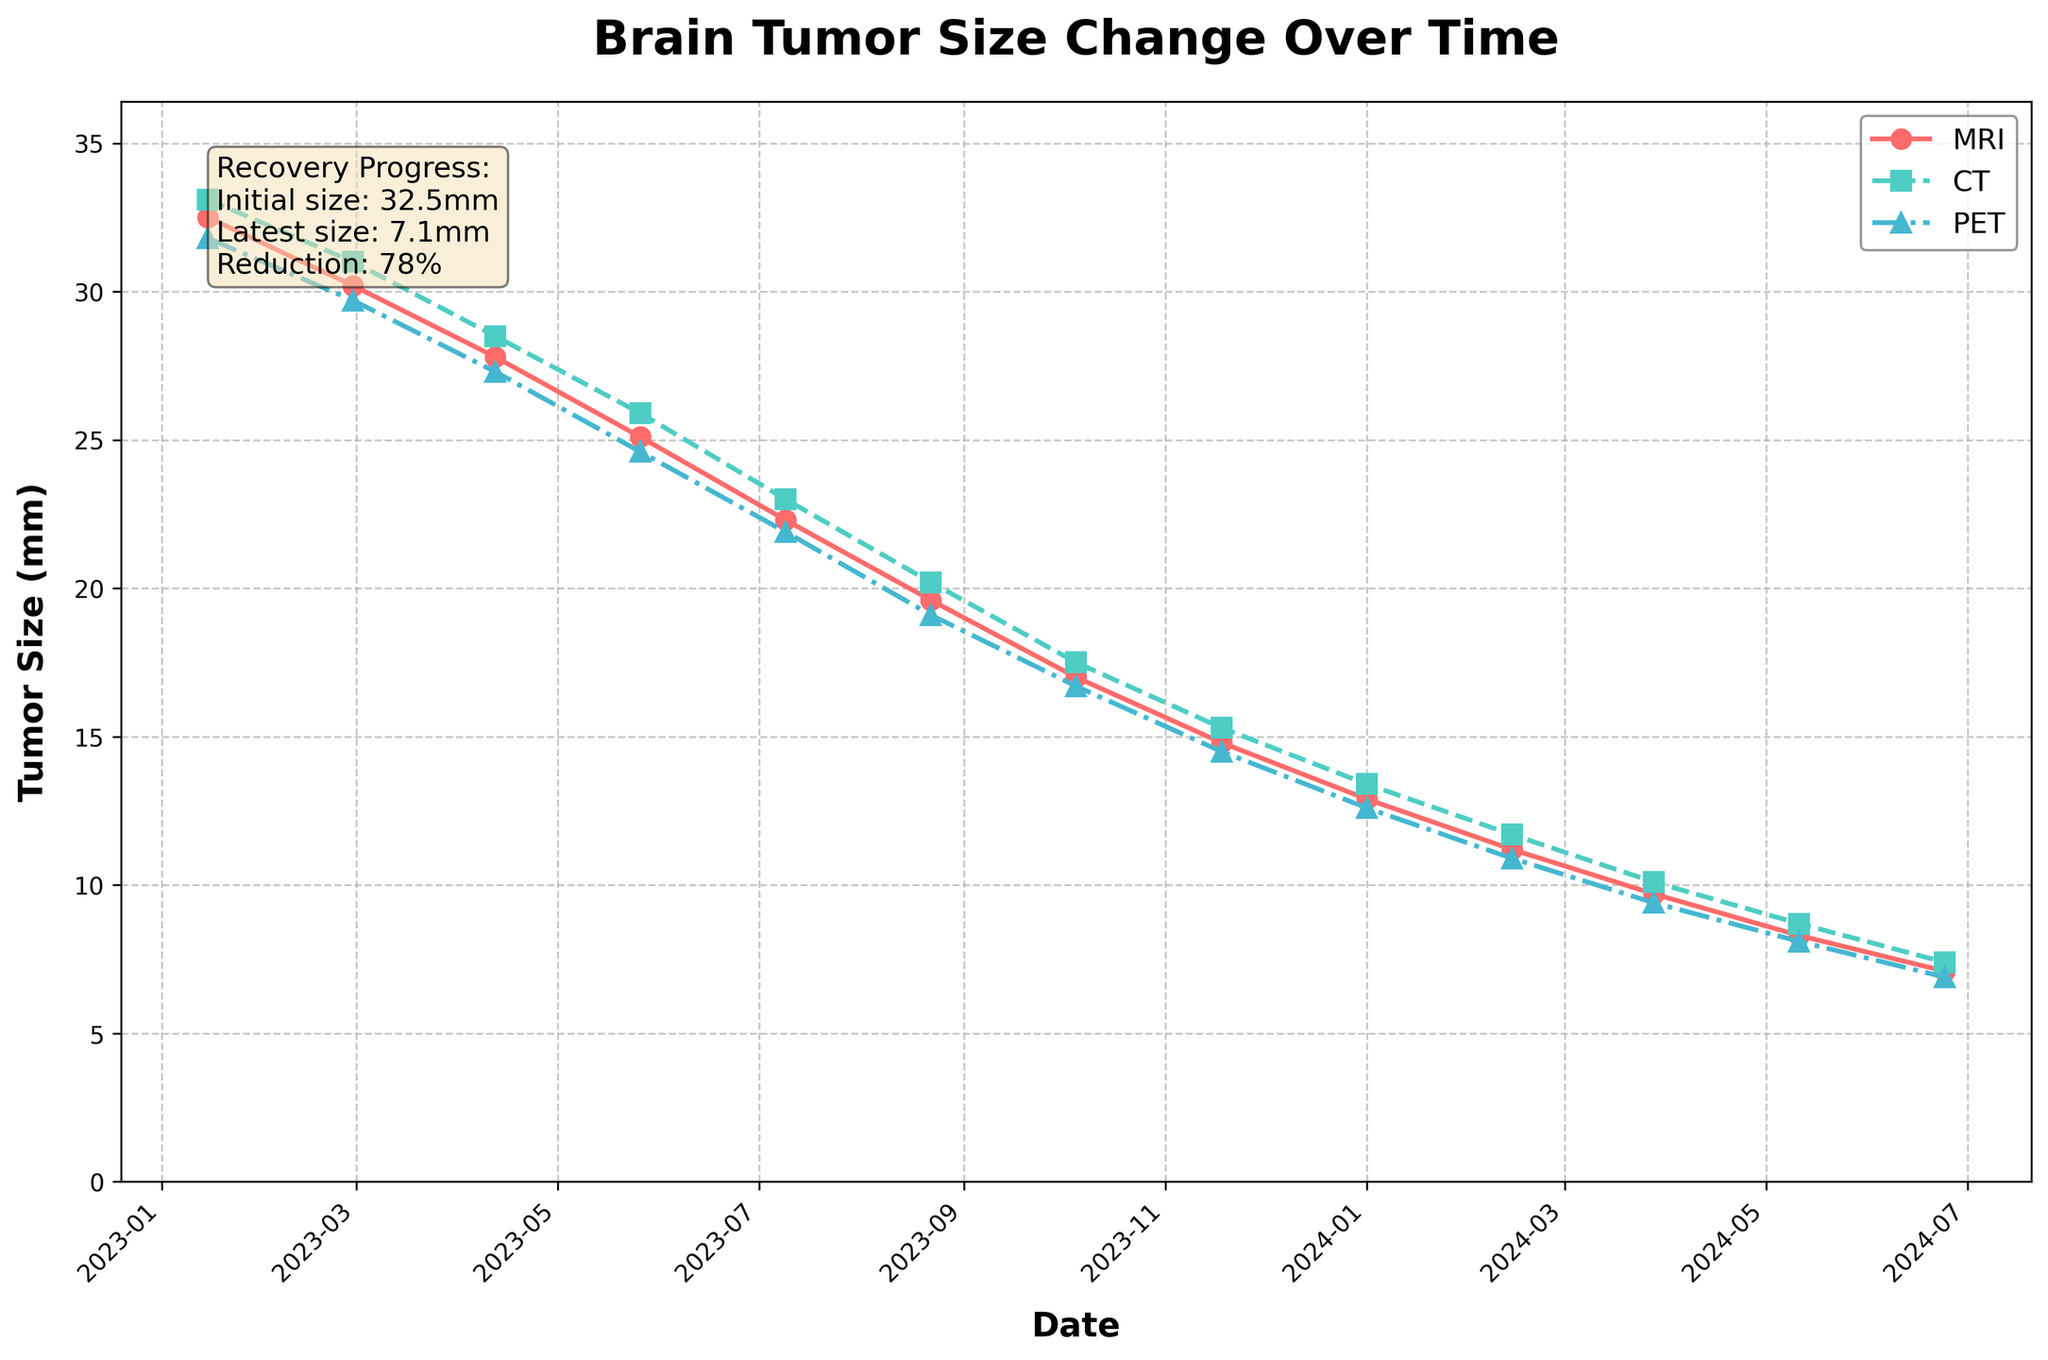What's the general trend of brain tumor size over time for all three imaging techniques? The plot shows that the brain tumor size for all three techniques (MRI, CT, PET) decreases over time. This can be observed from the downward slopes of all three lines on the chart.
Answer: Decreasing By how much did the MRI-measured brain tumor size decrease between January 2023 and June 2024? The MRI-measured tumor size in January 2023 was 32.5 mm and in June 2024 was 7.1 mm. The amount of decrease is 32.5 - 7.1 = 25.4 mm.
Answer: 25.4 mm Which imaging technique shows the smallest brain tumor size in June 2024? Looking at the values for June 2024, MRI shows 7.1 mm, CT shows 7.4 mm, and PET shows 6.9 mm. PET has the smallest value.
Answer: PET How much did the brain tumor size measured by CT decrease between February 2024 and March 2024? From February 2024 to March 2024, the brain tumor size measured by CT went from 11.7 mm to 10.1 mm. The decrease is 11.7 - 10.1 = 1.6 mm.
Answer: 1.6 mm Which imaging technique had the most consistent measurement pattern over the time period? All three lines (MRI, CT, PET) show a consistent downward trend but PET appears slightly smoother and less prone to sharp changes compared to MRI and CT.
Answer: PET What is the approximate percentage reduction in brain tumor size recorded by MRI from January 2023 to June 2024? The initial MRI size in January 2023 was 32.5 mm, and in June 2024, it was 7.1 mm. The reduction is 25.4 mm. The percentage reduction is (25.4 / 32.5) * 100 ≈ 78%.
Answer: 78% Was there any month where CT measured a higher tumor size than MRI? Yes, in January 2023, CT (33.1 mm) measured a higher tumor size than MRI (32.5 mm). In the other months, MRI measurements were either very close or slightly lower than CT.
Answer: Yes In which month did PET measurements first drop below 20 mm? PET measurements first dropped below 20 mm in August 2023 when the PET value was 19.1 mm.
Answer: August 2023 